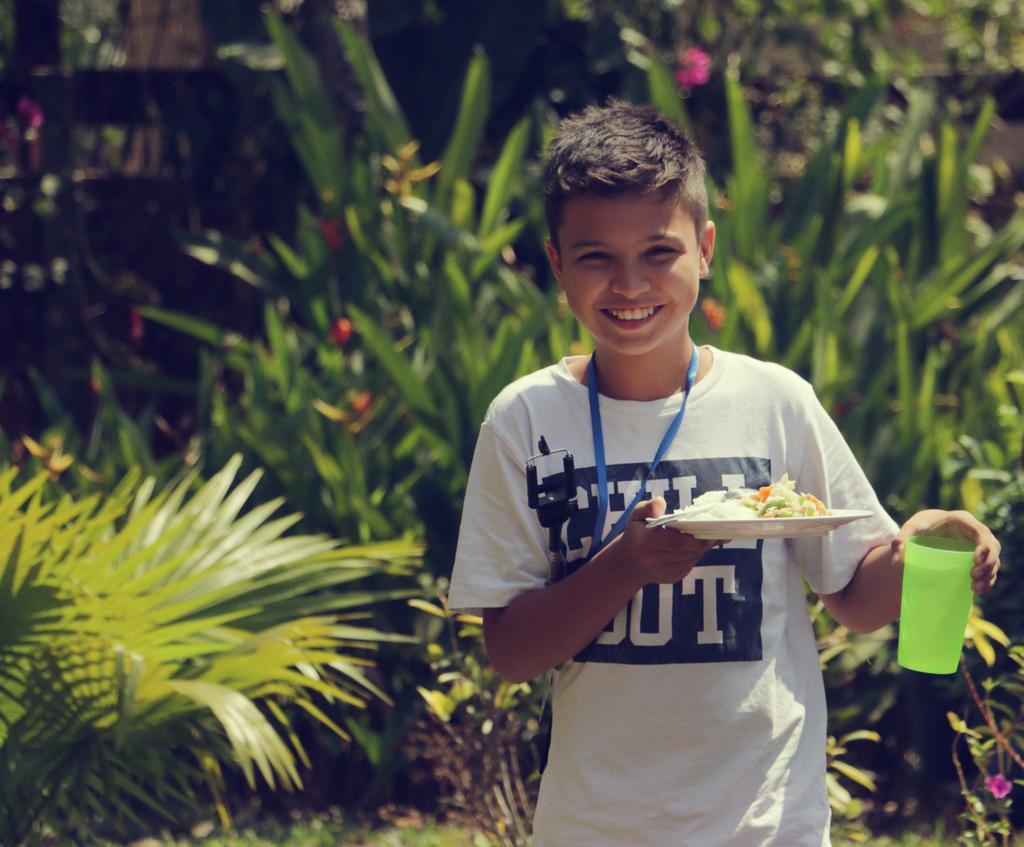Describe this image in one or two sentences. In this image we can see a kid wearing white color T-shirt, blue color ID card holding glass and plate in his hands and in the background of the image there are some plants and trees. 